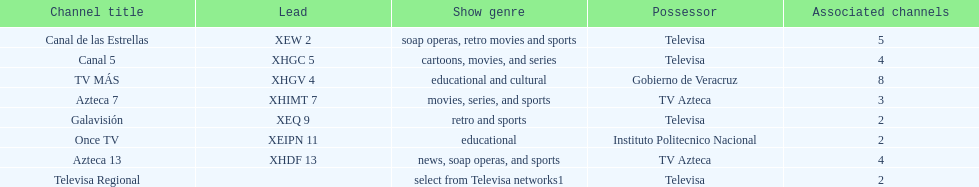Would you be able to parse every entry in this table? {'header': ['Channel title', 'Lead', 'Show genre', 'Possessor', 'Associated channels'], 'rows': [['Canal de las Estrellas', 'XEW 2', 'soap operas, retro movies and sports', 'Televisa', '5'], ['Canal 5', 'XHGC 5', 'cartoons, movies, and series', 'Televisa', '4'], ['TV MÁS', 'XHGV 4', 'educational and cultural', 'Gobierno de Veracruz', '8'], ['Azteca 7', 'XHIMT 7', 'movies, series, and sports', 'TV Azteca', '3'], ['Galavisión', 'XEQ 9', 'retro and sports', 'Televisa', '2'], ['Once TV', 'XEIPN 11', 'educational', 'Instituto Politecnico Nacional', '2'], ['Azteca 13', 'XHDF 13', 'news, soap operas, and sports', 'TV Azteca', '4'], ['Televisa Regional', '', 'select from Televisa networks1', 'Televisa', '2']]} How many networks show soap operas? 2. 